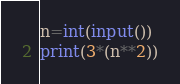Convert code to text. <code><loc_0><loc_0><loc_500><loc_500><_Python_>n=int(input())
print(3*(n**2))</code> 